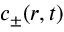Convert formula to latex. <formula><loc_0><loc_0><loc_500><loc_500>c _ { \pm } ( r , t )</formula> 